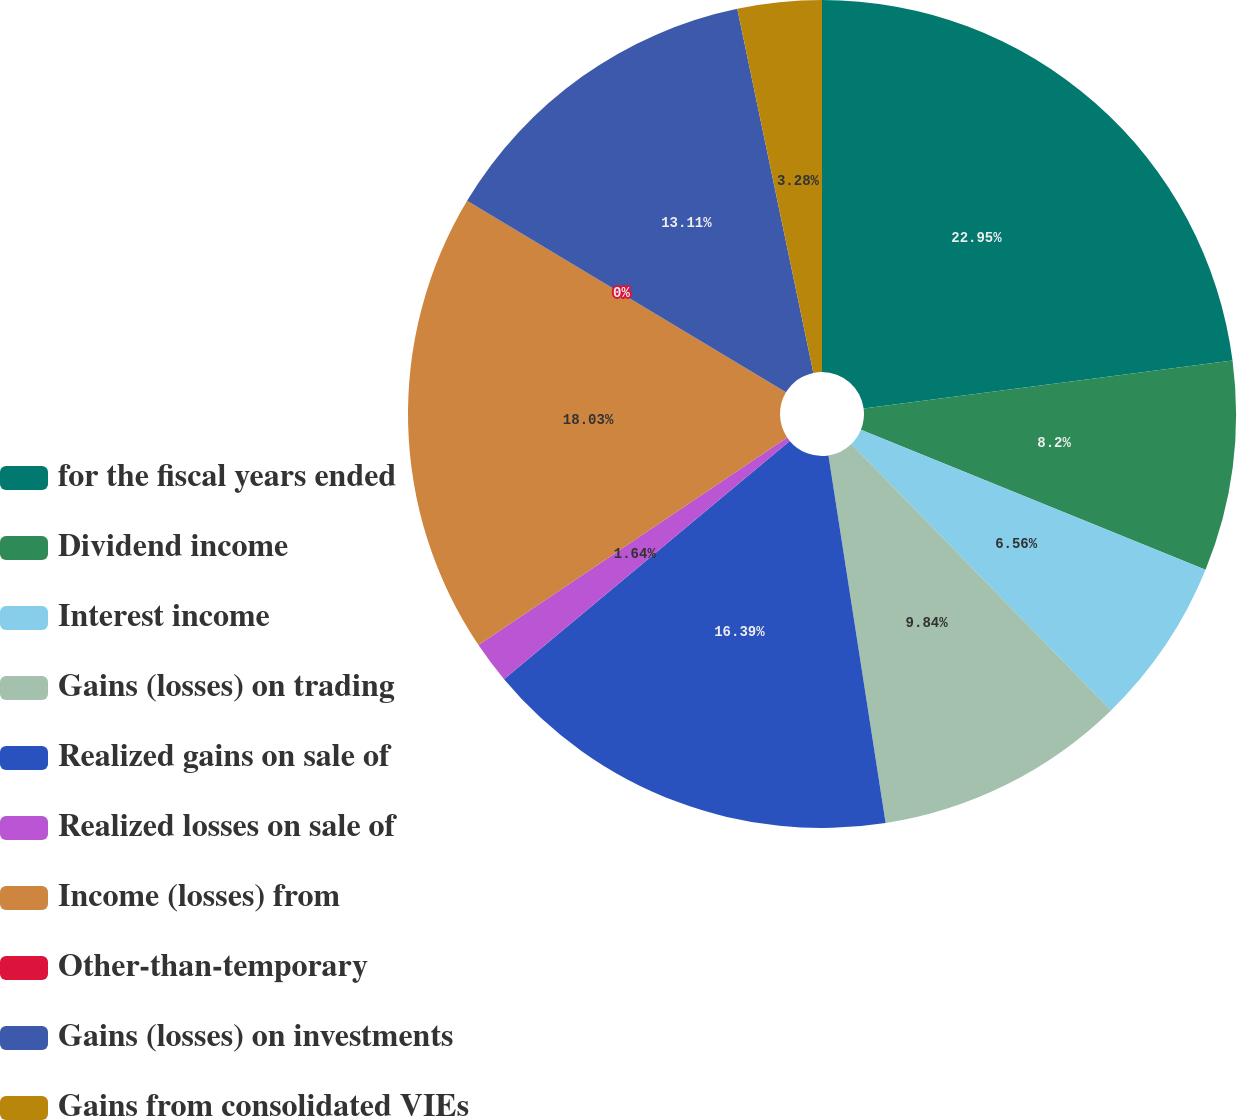Convert chart to OTSL. <chart><loc_0><loc_0><loc_500><loc_500><pie_chart><fcel>for the fiscal years ended<fcel>Dividend income<fcel>Interest income<fcel>Gains (losses) on trading<fcel>Realized gains on sale of<fcel>Realized losses on sale of<fcel>Income (losses) from<fcel>Other-than-temporary<fcel>Gains (losses) on investments<fcel>Gains from consolidated VIEs<nl><fcel>22.94%<fcel>8.2%<fcel>6.56%<fcel>9.84%<fcel>16.39%<fcel>1.64%<fcel>18.03%<fcel>0.0%<fcel>13.11%<fcel>3.28%<nl></chart> 